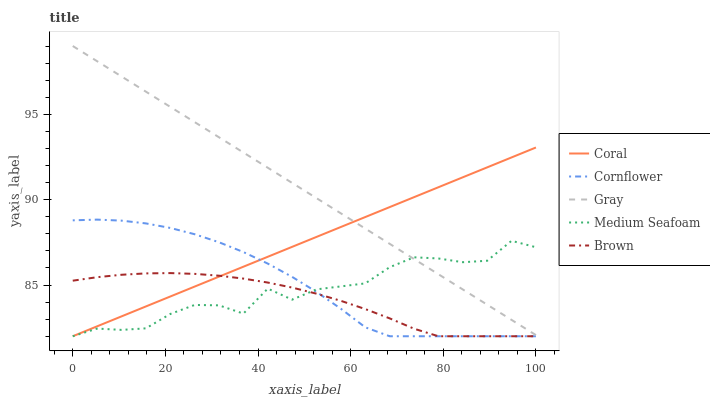Does Brown have the minimum area under the curve?
Answer yes or no. Yes. Does Gray have the maximum area under the curve?
Answer yes or no. Yes. Does Coral have the minimum area under the curve?
Answer yes or no. No. Does Coral have the maximum area under the curve?
Answer yes or no. No. Is Coral the smoothest?
Answer yes or no. Yes. Is Medium Seafoam the roughest?
Answer yes or no. Yes. Is Medium Seafoam the smoothest?
Answer yes or no. No. Is Coral the roughest?
Answer yes or no. No. Does Gray have the lowest value?
Answer yes or no. No. Does Gray have the highest value?
Answer yes or no. Yes. Does Coral have the highest value?
Answer yes or no. No. Is Cornflower less than Gray?
Answer yes or no. Yes. Is Gray greater than Brown?
Answer yes or no. Yes. Does Cornflower intersect Gray?
Answer yes or no. No. 